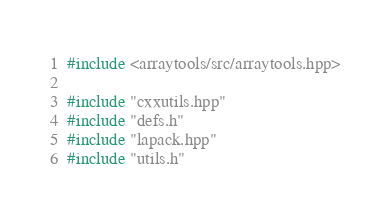<code> <loc_0><loc_0><loc_500><loc_500><_C++_>#include <arraytools/src/arraytools.hpp>

#include "cxxutils.hpp"
#include "defs.h"
#include "lapack.hpp"
#include "utils.h"

</code> 